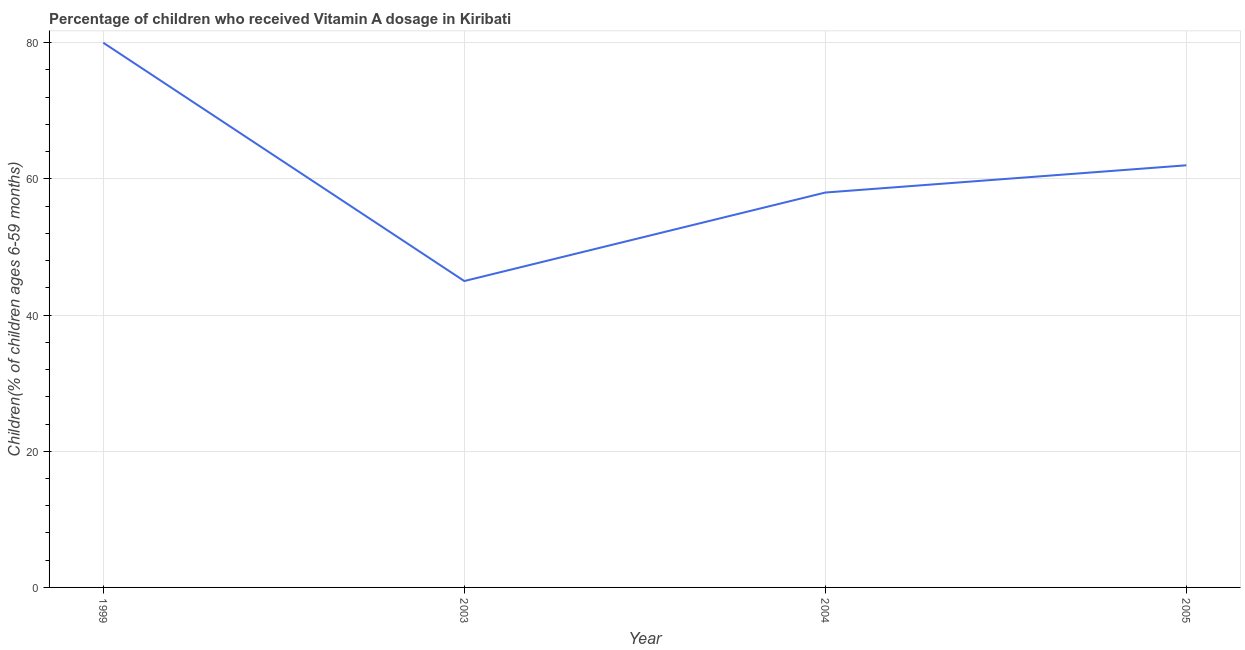What is the vitamin a supplementation coverage rate in 2003?
Your answer should be compact. 45. Across all years, what is the maximum vitamin a supplementation coverage rate?
Your response must be concise. 80. Across all years, what is the minimum vitamin a supplementation coverage rate?
Provide a short and direct response. 45. In which year was the vitamin a supplementation coverage rate maximum?
Ensure brevity in your answer.  1999. In which year was the vitamin a supplementation coverage rate minimum?
Ensure brevity in your answer.  2003. What is the sum of the vitamin a supplementation coverage rate?
Make the answer very short. 245. What is the difference between the vitamin a supplementation coverage rate in 1999 and 2005?
Offer a terse response. 18. What is the average vitamin a supplementation coverage rate per year?
Provide a short and direct response. 61.25. In how many years, is the vitamin a supplementation coverage rate greater than 12 %?
Provide a succinct answer. 4. Do a majority of the years between 2003 and 2005 (inclusive) have vitamin a supplementation coverage rate greater than 60 %?
Provide a short and direct response. No. What is the ratio of the vitamin a supplementation coverage rate in 1999 to that in 2004?
Give a very brief answer. 1.38. Is the vitamin a supplementation coverage rate in 1999 less than that in 2005?
Offer a very short reply. No. What is the difference between the highest and the second highest vitamin a supplementation coverage rate?
Your answer should be compact. 18. Is the sum of the vitamin a supplementation coverage rate in 2004 and 2005 greater than the maximum vitamin a supplementation coverage rate across all years?
Your response must be concise. Yes. What is the difference between the highest and the lowest vitamin a supplementation coverage rate?
Your answer should be very brief. 35. In how many years, is the vitamin a supplementation coverage rate greater than the average vitamin a supplementation coverage rate taken over all years?
Your answer should be compact. 2. How many years are there in the graph?
Offer a terse response. 4. Are the values on the major ticks of Y-axis written in scientific E-notation?
Offer a terse response. No. What is the title of the graph?
Give a very brief answer. Percentage of children who received Vitamin A dosage in Kiribati. What is the label or title of the X-axis?
Your answer should be compact. Year. What is the label or title of the Y-axis?
Give a very brief answer. Children(% of children ages 6-59 months). What is the Children(% of children ages 6-59 months) of 2003?
Your answer should be compact. 45. What is the Children(% of children ages 6-59 months) of 2004?
Offer a terse response. 58. What is the difference between the Children(% of children ages 6-59 months) in 1999 and 2003?
Your response must be concise. 35. What is the difference between the Children(% of children ages 6-59 months) in 2003 and 2004?
Make the answer very short. -13. What is the difference between the Children(% of children ages 6-59 months) in 2003 and 2005?
Your response must be concise. -17. What is the difference between the Children(% of children ages 6-59 months) in 2004 and 2005?
Give a very brief answer. -4. What is the ratio of the Children(% of children ages 6-59 months) in 1999 to that in 2003?
Provide a short and direct response. 1.78. What is the ratio of the Children(% of children ages 6-59 months) in 1999 to that in 2004?
Offer a very short reply. 1.38. What is the ratio of the Children(% of children ages 6-59 months) in 1999 to that in 2005?
Offer a terse response. 1.29. What is the ratio of the Children(% of children ages 6-59 months) in 2003 to that in 2004?
Offer a very short reply. 0.78. What is the ratio of the Children(% of children ages 6-59 months) in 2003 to that in 2005?
Your answer should be very brief. 0.73. What is the ratio of the Children(% of children ages 6-59 months) in 2004 to that in 2005?
Provide a succinct answer. 0.94. 